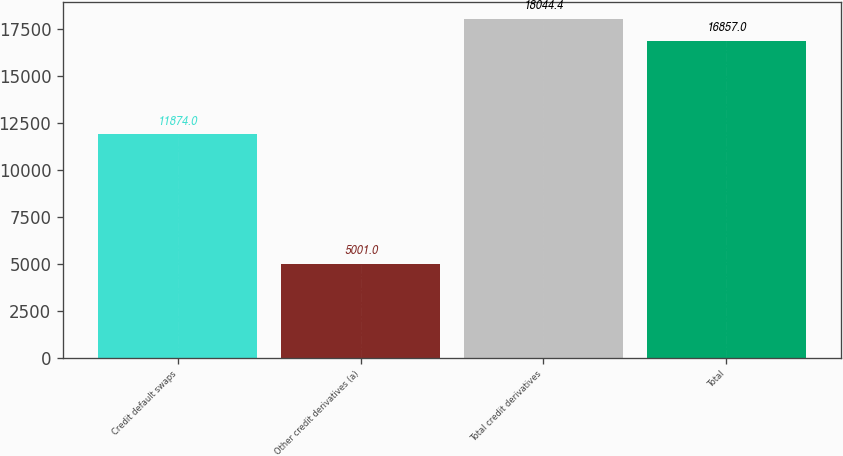Convert chart. <chart><loc_0><loc_0><loc_500><loc_500><bar_chart><fcel>Credit default swaps<fcel>Other credit derivatives (a)<fcel>Total credit derivatives<fcel>Total<nl><fcel>11874<fcel>5001<fcel>18044.4<fcel>16857<nl></chart> 